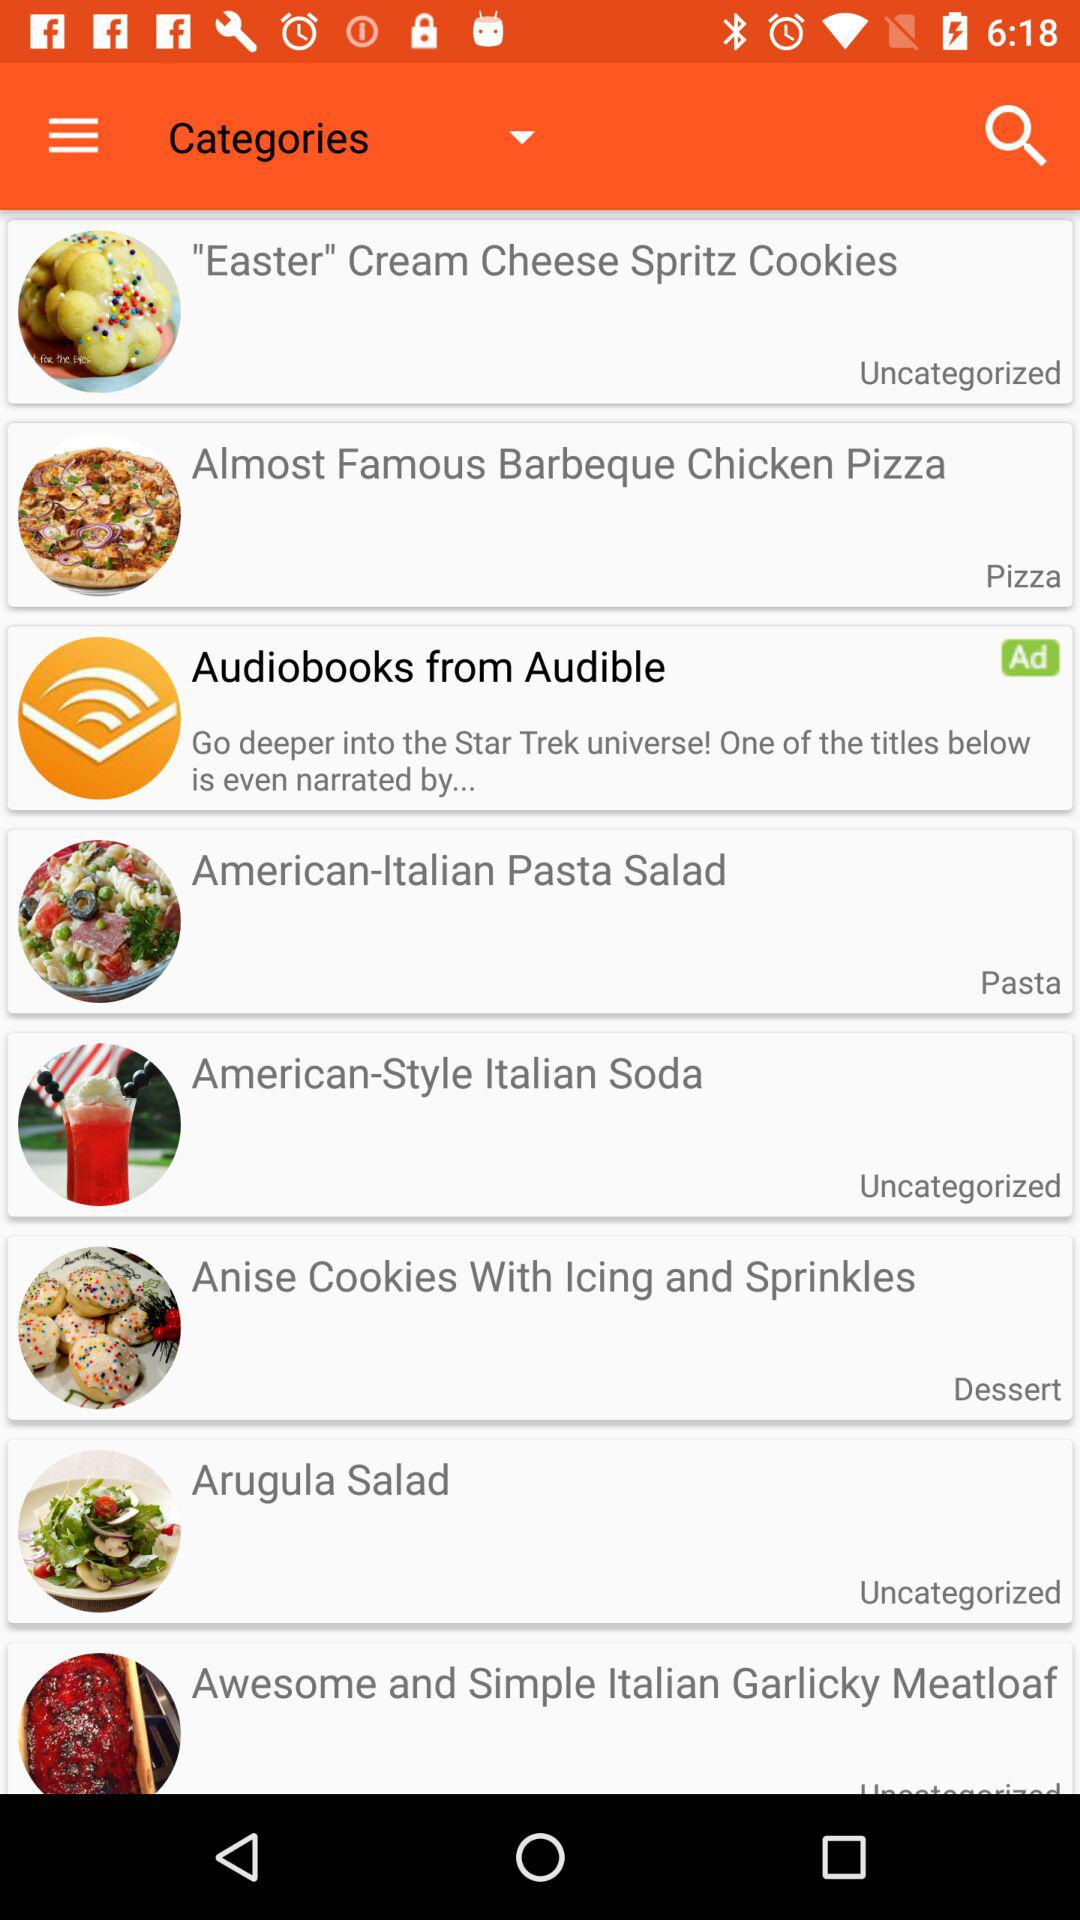What category does "American-Italian Pasta Salad" fall under? "American-Italian Pasta Salad" falls under the "Pasta" category. 